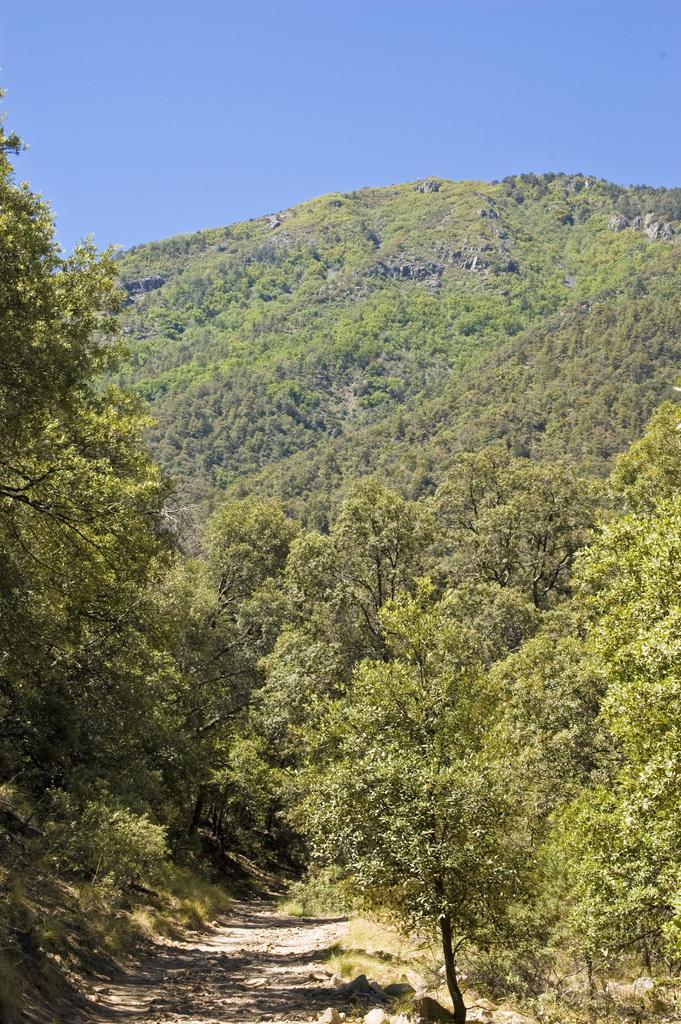How would you summarize this image in a sentence or two? In this image we can see trees and a mountain. At the top of the image, we can see the sky. At the bottom of the image, we can see the land. 